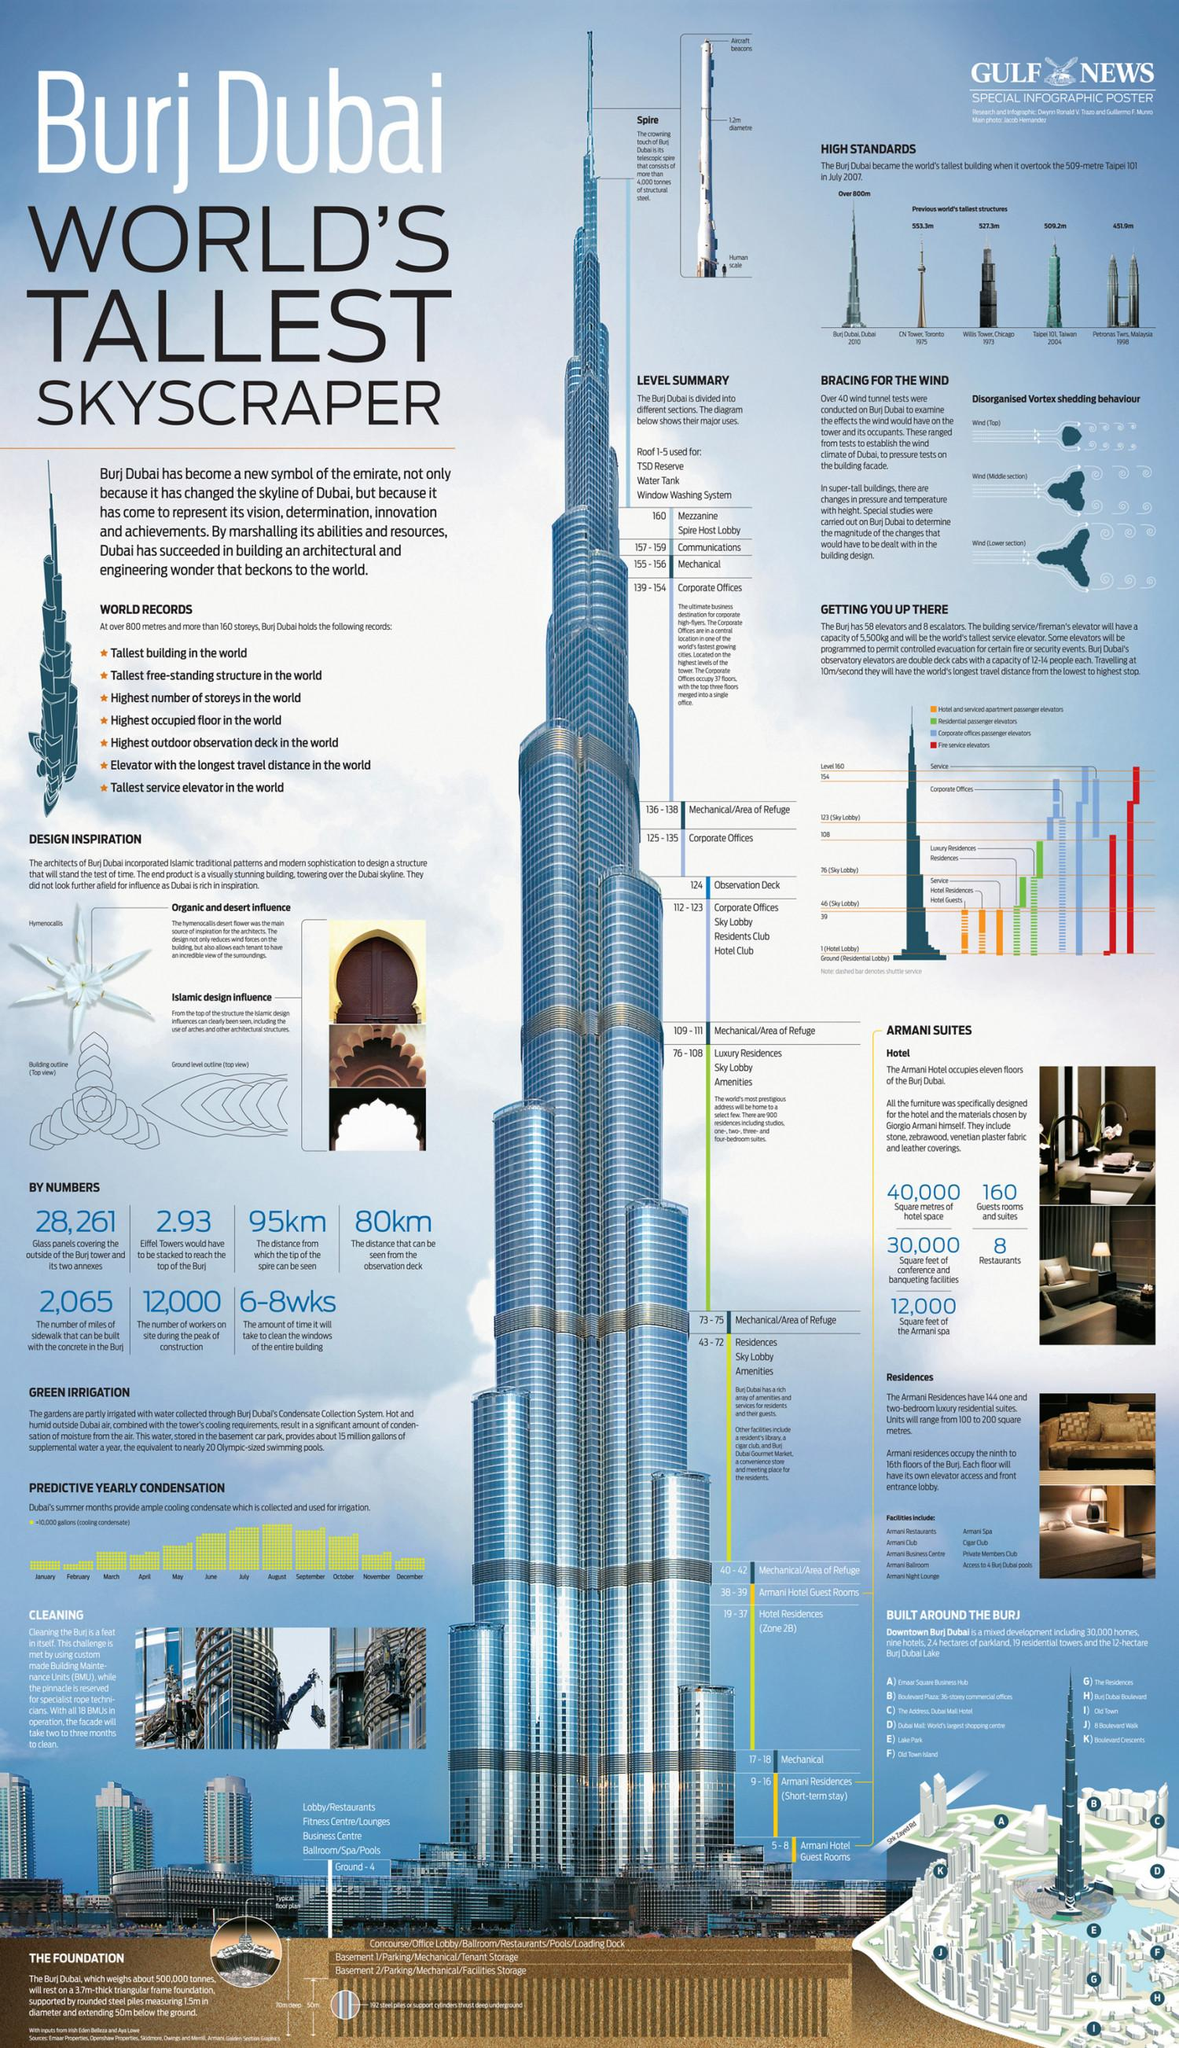Give some essential details in this illustration. The total number of glass panels used to cover the exterior of the Burj tower and its annexes is 28,261. The observation deck can see a distance of 80 kilometers. There are 160 guest rooms and suites in the Armani Hotel. Giorgio Armani, a renowned fashion designer, designed the furniture for the Armani hotel. There are eight restaurants located in the Armani Hotel. 